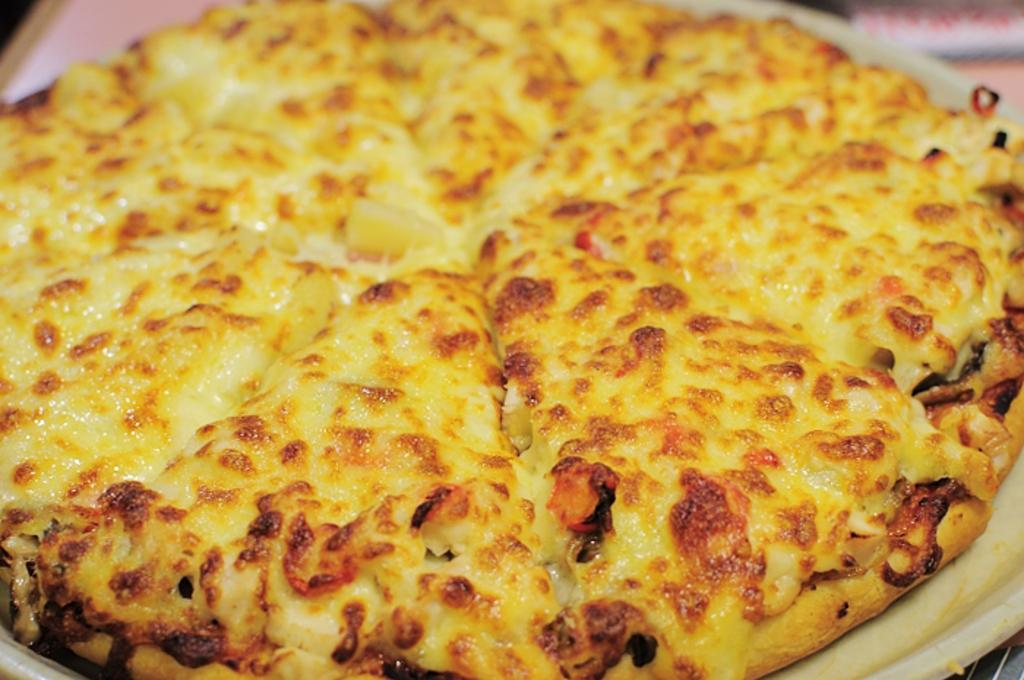What type of food is the main subject of the image? There is a pizza in the image. Can you describe the background of the image? The background of the image is blurry. What type of drug can be seen in the image? There is no drug present in the image; it is a pizza and a blurry background. 